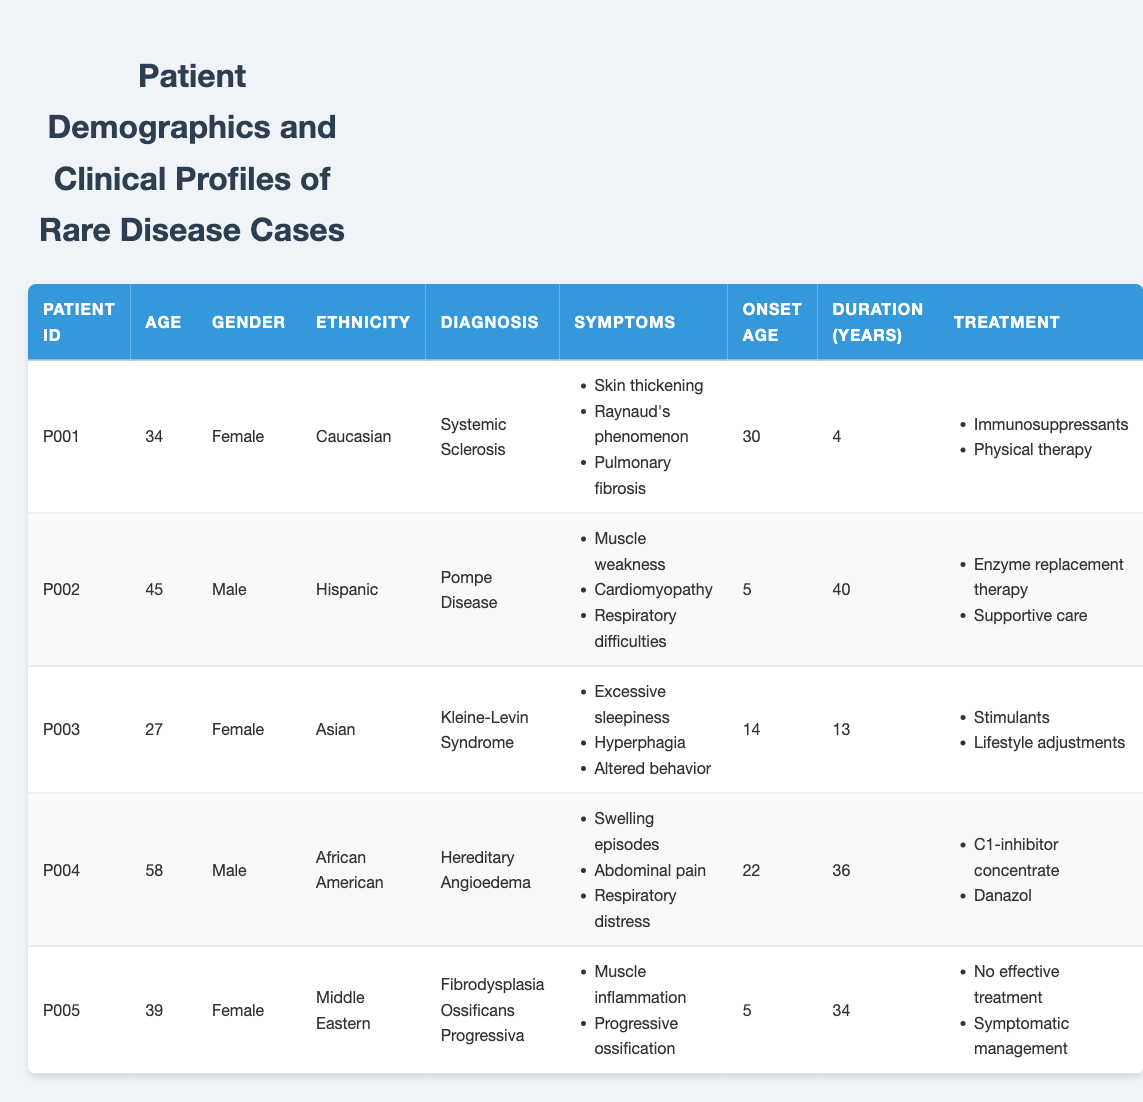What is the gender distribution of the patients? There are five patients listed in the table. Out of these, three are female (P001, P003, P005) and two are male (P002, P004). Therefore, the gender distribution is 3 females and 2 males.
Answer: 3 females and 2 males Which patient has the longest duration of illness? The longest duration of illness can be found by looking at the "Duration (Years)" column. P002 has been ill for 40 years, which is the highest duration among all patients.
Answer: P002 What percentage of patients have "Pulmonary fibrosis" as a symptom? There are 5 patients in total, and only one patient (P001) lists "Pulmonary fibrosis" among their symptoms. To find the percentage, we calculate (1/5) * 100, which equals 20%.
Answer: 20% Is there any patient with no effective treatment listed? We can determine this by checking the "Treatment" column for each patient. P005 has "No effective treatment" listed as one of their treatments. Therefore, the answer is yes.
Answer: Yes What is the average age of the patients? The ages of the patients are 34, 45, 27, 58, and 39. Summing these values we get 203 (34 + 45 + 27 + 58 + 39), and dividing by the number of patients (5), we find the average age to be 40.6.
Answer: 40.6 Which ethnic group has the highest representation in the table? By counting the number of occurrences of each ethnicity: Caucasian has 1 (P001), Hispanic has 1 (P002), Asian has 1 (P003), African American has 1 (P004), and Middle Eastern has 1 (P005). All ethnic groups have equal representation, with one patient in each group.
Answer: None, all are equally represented How many patients have an onset age of 5? Only two patients (P002 and P005) list an onset age of 5. Thus, the count is 2.
Answer: 2 What is the difference in ages between the youngest and oldest patient? The youngest patient is P003, who is 27, and the oldest patient is P004, who is 58. By calculating the difference, 58 - 27 gives us 31.
Answer: 31 How many patients have “Respiratory difficulties” listed as a symptom? Only P002 mentions "Respiratory difficulties" among their symptoms, so the count is 1.
Answer: 1 